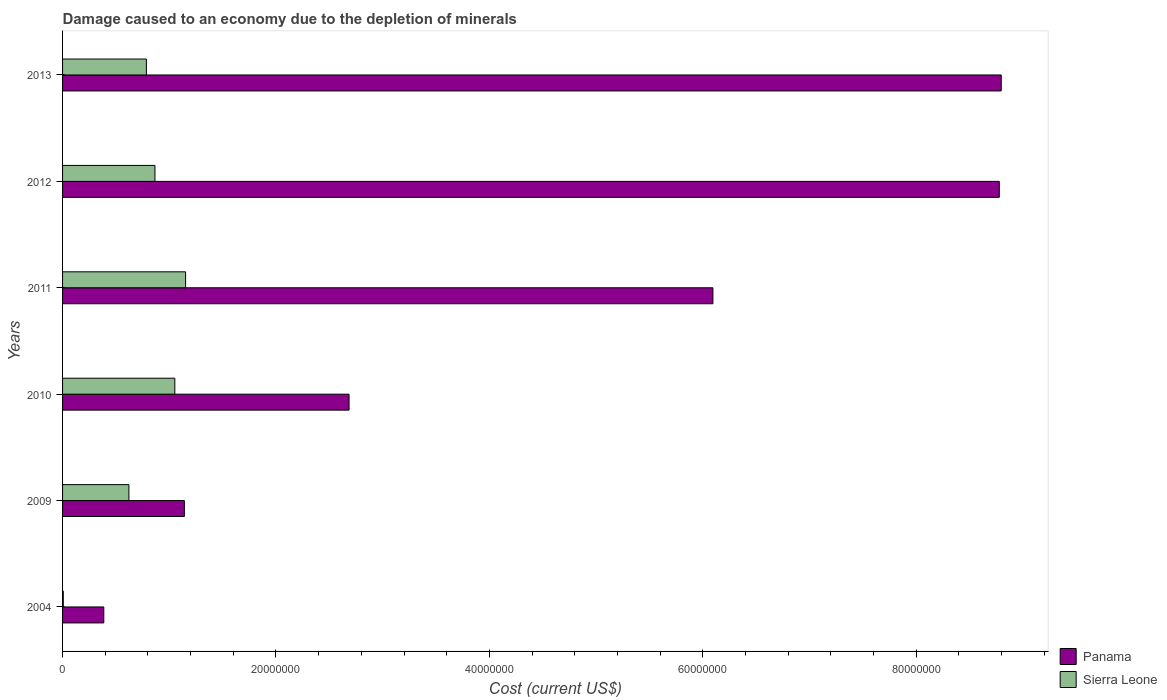Are the number of bars per tick equal to the number of legend labels?
Give a very brief answer. Yes. How many bars are there on the 3rd tick from the top?
Offer a very short reply. 2. What is the label of the 2nd group of bars from the top?
Offer a terse response. 2012. What is the cost of damage caused due to the depletion of minerals in Sierra Leone in 2012?
Provide a succinct answer. 8.66e+06. Across all years, what is the maximum cost of damage caused due to the depletion of minerals in Sierra Leone?
Give a very brief answer. 1.15e+07. Across all years, what is the minimum cost of damage caused due to the depletion of minerals in Panama?
Make the answer very short. 3.86e+06. In which year was the cost of damage caused due to the depletion of minerals in Panama maximum?
Keep it short and to the point. 2013. What is the total cost of damage caused due to the depletion of minerals in Panama in the graph?
Your answer should be compact. 2.79e+08. What is the difference between the cost of damage caused due to the depletion of minerals in Panama in 2010 and that in 2012?
Your answer should be compact. -6.09e+07. What is the difference between the cost of damage caused due to the depletion of minerals in Sierra Leone in 2010 and the cost of damage caused due to the depletion of minerals in Panama in 2012?
Offer a terse response. -7.73e+07. What is the average cost of damage caused due to the depletion of minerals in Sierra Leone per year?
Make the answer very short. 7.48e+06. In the year 2009, what is the difference between the cost of damage caused due to the depletion of minerals in Panama and cost of damage caused due to the depletion of minerals in Sierra Leone?
Keep it short and to the point. 5.20e+06. What is the ratio of the cost of damage caused due to the depletion of minerals in Panama in 2011 to that in 2013?
Offer a very short reply. 0.69. Is the difference between the cost of damage caused due to the depletion of minerals in Panama in 2004 and 2009 greater than the difference between the cost of damage caused due to the depletion of minerals in Sierra Leone in 2004 and 2009?
Your response must be concise. No. What is the difference between the highest and the second highest cost of damage caused due to the depletion of minerals in Panama?
Provide a short and direct response. 1.81e+05. What is the difference between the highest and the lowest cost of damage caused due to the depletion of minerals in Sierra Leone?
Your answer should be compact. 1.15e+07. In how many years, is the cost of damage caused due to the depletion of minerals in Sierra Leone greater than the average cost of damage caused due to the depletion of minerals in Sierra Leone taken over all years?
Your response must be concise. 4. Is the sum of the cost of damage caused due to the depletion of minerals in Panama in 2004 and 2013 greater than the maximum cost of damage caused due to the depletion of minerals in Sierra Leone across all years?
Offer a very short reply. Yes. What does the 1st bar from the top in 2004 represents?
Your response must be concise. Sierra Leone. What does the 2nd bar from the bottom in 2012 represents?
Your response must be concise. Sierra Leone. How many years are there in the graph?
Offer a very short reply. 6. What is the difference between two consecutive major ticks on the X-axis?
Offer a terse response. 2.00e+07. Are the values on the major ticks of X-axis written in scientific E-notation?
Your response must be concise. No. How are the legend labels stacked?
Your response must be concise. Vertical. What is the title of the graph?
Give a very brief answer. Damage caused to an economy due to the depletion of minerals. What is the label or title of the X-axis?
Offer a very short reply. Cost (current US$). What is the label or title of the Y-axis?
Keep it short and to the point. Years. What is the Cost (current US$) in Panama in 2004?
Your answer should be very brief. 3.86e+06. What is the Cost (current US$) of Sierra Leone in 2004?
Keep it short and to the point. 6.80e+04. What is the Cost (current US$) in Panama in 2009?
Offer a very short reply. 1.14e+07. What is the Cost (current US$) in Sierra Leone in 2009?
Offer a very short reply. 6.22e+06. What is the Cost (current US$) in Panama in 2010?
Ensure brevity in your answer.  2.69e+07. What is the Cost (current US$) in Sierra Leone in 2010?
Keep it short and to the point. 1.05e+07. What is the Cost (current US$) of Panama in 2011?
Your answer should be compact. 6.10e+07. What is the Cost (current US$) in Sierra Leone in 2011?
Provide a short and direct response. 1.15e+07. What is the Cost (current US$) in Panama in 2012?
Make the answer very short. 8.78e+07. What is the Cost (current US$) of Sierra Leone in 2012?
Your response must be concise. 8.66e+06. What is the Cost (current US$) in Panama in 2013?
Provide a succinct answer. 8.80e+07. What is the Cost (current US$) of Sierra Leone in 2013?
Give a very brief answer. 7.86e+06. Across all years, what is the maximum Cost (current US$) in Panama?
Your answer should be compact. 8.80e+07. Across all years, what is the maximum Cost (current US$) in Sierra Leone?
Keep it short and to the point. 1.15e+07. Across all years, what is the minimum Cost (current US$) of Panama?
Offer a terse response. 3.86e+06. Across all years, what is the minimum Cost (current US$) of Sierra Leone?
Offer a terse response. 6.80e+04. What is the total Cost (current US$) in Panama in the graph?
Your answer should be compact. 2.79e+08. What is the total Cost (current US$) of Sierra Leone in the graph?
Your answer should be very brief. 4.49e+07. What is the difference between the Cost (current US$) in Panama in 2004 and that in 2009?
Provide a short and direct response. -7.55e+06. What is the difference between the Cost (current US$) in Sierra Leone in 2004 and that in 2009?
Keep it short and to the point. -6.15e+06. What is the difference between the Cost (current US$) in Panama in 2004 and that in 2010?
Make the answer very short. -2.30e+07. What is the difference between the Cost (current US$) of Sierra Leone in 2004 and that in 2010?
Keep it short and to the point. -1.05e+07. What is the difference between the Cost (current US$) of Panama in 2004 and that in 2011?
Keep it short and to the point. -5.71e+07. What is the difference between the Cost (current US$) of Sierra Leone in 2004 and that in 2011?
Your response must be concise. -1.15e+07. What is the difference between the Cost (current US$) in Panama in 2004 and that in 2012?
Offer a terse response. -8.39e+07. What is the difference between the Cost (current US$) in Sierra Leone in 2004 and that in 2012?
Your answer should be compact. -8.59e+06. What is the difference between the Cost (current US$) of Panama in 2004 and that in 2013?
Offer a terse response. -8.41e+07. What is the difference between the Cost (current US$) in Sierra Leone in 2004 and that in 2013?
Ensure brevity in your answer.  -7.79e+06. What is the difference between the Cost (current US$) in Panama in 2009 and that in 2010?
Your answer should be compact. -1.54e+07. What is the difference between the Cost (current US$) in Sierra Leone in 2009 and that in 2010?
Provide a succinct answer. -4.30e+06. What is the difference between the Cost (current US$) of Panama in 2009 and that in 2011?
Give a very brief answer. -4.95e+07. What is the difference between the Cost (current US$) of Sierra Leone in 2009 and that in 2011?
Your answer should be very brief. -5.31e+06. What is the difference between the Cost (current US$) in Panama in 2009 and that in 2012?
Keep it short and to the point. -7.64e+07. What is the difference between the Cost (current US$) of Sierra Leone in 2009 and that in 2012?
Your answer should be compact. -2.44e+06. What is the difference between the Cost (current US$) of Panama in 2009 and that in 2013?
Your answer should be very brief. -7.66e+07. What is the difference between the Cost (current US$) in Sierra Leone in 2009 and that in 2013?
Offer a terse response. -1.64e+06. What is the difference between the Cost (current US$) of Panama in 2010 and that in 2011?
Your answer should be very brief. -3.41e+07. What is the difference between the Cost (current US$) in Sierra Leone in 2010 and that in 2011?
Keep it short and to the point. -1.01e+06. What is the difference between the Cost (current US$) in Panama in 2010 and that in 2012?
Your answer should be compact. -6.09e+07. What is the difference between the Cost (current US$) of Sierra Leone in 2010 and that in 2012?
Keep it short and to the point. 1.86e+06. What is the difference between the Cost (current US$) of Panama in 2010 and that in 2013?
Provide a short and direct response. -6.11e+07. What is the difference between the Cost (current US$) of Sierra Leone in 2010 and that in 2013?
Give a very brief answer. 2.66e+06. What is the difference between the Cost (current US$) of Panama in 2011 and that in 2012?
Ensure brevity in your answer.  -2.68e+07. What is the difference between the Cost (current US$) of Sierra Leone in 2011 and that in 2012?
Give a very brief answer. 2.87e+06. What is the difference between the Cost (current US$) in Panama in 2011 and that in 2013?
Offer a terse response. -2.70e+07. What is the difference between the Cost (current US$) of Sierra Leone in 2011 and that in 2013?
Offer a very short reply. 3.67e+06. What is the difference between the Cost (current US$) of Panama in 2012 and that in 2013?
Keep it short and to the point. -1.81e+05. What is the difference between the Cost (current US$) in Sierra Leone in 2012 and that in 2013?
Provide a succinct answer. 8.02e+05. What is the difference between the Cost (current US$) in Panama in 2004 and the Cost (current US$) in Sierra Leone in 2009?
Your answer should be very brief. -2.35e+06. What is the difference between the Cost (current US$) of Panama in 2004 and the Cost (current US$) of Sierra Leone in 2010?
Provide a succinct answer. -6.66e+06. What is the difference between the Cost (current US$) in Panama in 2004 and the Cost (current US$) in Sierra Leone in 2011?
Make the answer very short. -7.67e+06. What is the difference between the Cost (current US$) in Panama in 2004 and the Cost (current US$) in Sierra Leone in 2012?
Ensure brevity in your answer.  -4.80e+06. What is the difference between the Cost (current US$) of Panama in 2004 and the Cost (current US$) of Sierra Leone in 2013?
Give a very brief answer. -3.99e+06. What is the difference between the Cost (current US$) of Panama in 2009 and the Cost (current US$) of Sierra Leone in 2010?
Provide a short and direct response. 8.95e+05. What is the difference between the Cost (current US$) in Panama in 2009 and the Cost (current US$) in Sierra Leone in 2011?
Keep it short and to the point. -1.13e+05. What is the difference between the Cost (current US$) in Panama in 2009 and the Cost (current US$) in Sierra Leone in 2012?
Keep it short and to the point. 2.76e+06. What is the difference between the Cost (current US$) in Panama in 2009 and the Cost (current US$) in Sierra Leone in 2013?
Offer a very short reply. 3.56e+06. What is the difference between the Cost (current US$) in Panama in 2010 and the Cost (current US$) in Sierra Leone in 2011?
Make the answer very short. 1.53e+07. What is the difference between the Cost (current US$) of Panama in 2010 and the Cost (current US$) of Sierra Leone in 2012?
Give a very brief answer. 1.82e+07. What is the difference between the Cost (current US$) of Panama in 2010 and the Cost (current US$) of Sierra Leone in 2013?
Offer a terse response. 1.90e+07. What is the difference between the Cost (current US$) in Panama in 2011 and the Cost (current US$) in Sierra Leone in 2012?
Offer a very short reply. 5.23e+07. What is the difference between the Cost (current US$) of Panama in 2011 and the Cost (current US$) of Sierra Leone in 2013?
Give a very brief answer. 5.31e+07. What is the difference between the Cost (current US$) of Panama in 2012 and the Cost (current US$) of Sierra Leone in 2013?
Keep it short and to the point. 7.99e+07. What is the average Cost (current US$) of Panama per year?
Offer a very short reply. 4.65e+07. What is the average Cost (current US$) of Sierra Leone per year?
Give a very brief answer. 7.48e+06. In the year 2004, what is the difference between the Cost (current US$) of Panama and Cost (current US$) of Sierra Leone?
Your answer should be compact. 3.80e+06. In the year 2009, what is the difference between the Cost (current US$) in Panama and Cost (current US$) in Sierra Leone?
Your answer should be very brief. 5.20e+06. In the year 2010, what is the difference between the Cost (current US$) of Panama and Cost (current US$) of Sierra Leone?
Make the answer very short. 1.63e+07. In the year 2011, what is the difference between the Cost (current US$) in Panama and Cost (current US$) in Sierra Leone?
Your response must be concise. 4.94e+07. In the year 2012, what is the difference between the Cost (current US$) of Panama and Cost (current US$) of Sierra Leone?
Your answer should be very brief. 7.91e+07. In the year 2013, what is the difference between the Cost (current US$) of Panama and Cost (current US$) of Sierra Leone?
Provide a short and direct response. 8.01e+07. What is the ratio of the Cost (current US$) in Panama in 2004 to that in 2009?
Make the answer very short. 0.34. What is the ratio of the Cost (current US$) in Sierra Leone in 2004 to that in 2009?
Keep it short and to the point. 0.01. What is the ratio of the Cost (current US$) of Panama in 2004 to that in 2010?
Your answer should be very brief. 0.14. What is the ratio of the Cost (current US$) in Sierra Leone in 2004 to that in 2010?
Your response must be concise. 0.01. What is the ratio of the Cost (current US$) of Panama in 2004 to that in 2011?
Keep it short and to the point. 0.06. What is the ratio of the Cost (current US$) in Sierra Leone in 2004 to that in 2011?
Your answer should be compact. 0.01. What is the ratio of the Cost (current US$) in Panama in 2004 to that in 2012?
Provide a succinct answer. 0.04. What is the ratio of the Cost (current US$) of Sierra Leone in 2004 to that in 2012?
Provide a short and direct response. 0.01. What is the ratio of the Cost (current US$) of Panama in 2004 to that in 2013?
Give a very brief answer. 0.04. What is the ratio of the Cost (current US$) in Sierra Leone in 2004 to that in 2013?
Offer a very short reply. 0.01. What is the ratio of the Cost (current US$) of Panama in 2009 to that in 2010?
Make the answer very short. 0.43. What is the ratio of the Cost (current US$) in Sierra Leone in 2009 to that in 2010?
Offer a very short reply. 0.59. What is the ratio of the Cost (current US$) of Panama in 2009 to that in 2011?
Give a very brief answer. 0.19. What is the ratio of the Cost (current US$) of Sierra Leone in 2009 to that in 2011?
Provide a short and direct response. 0.54. What is the ratio of the Cost (current US$) of Panama in 2009 to that in 2012?
Provide a succinct answer. 0.13. What is the ratio of the Cost (current US$) in Sierra Leone in 2009 to that in 2012?
Your answer should be very brief. 0.72. What is the ratio of the Cost (current US$) of Panama in 2009 to that in 2013?
Ensure brevity in your answer.  0.13. What is the ratio of the Cost (current US$) in Sierra Leone in 2009 to that in 2013?
Give a very brief answer. 0.79. What is the ratio of the Cost (current US$) in Panama in 2010 to that in 2011?
Ensure brevity in your answer.  0.44. What is the ratio of the Cost (current US$) in Sierra Leone in 2010 to that in 2011?
Keep it short and to the point. 0.91. What is the ratio of the Cost (current US$) in Panama in 2010 to that in 2012?
Give a very brief answer. 0.31. What is the ratio of the Cost (current US$) of Sierra Leone in 2010 to that in 2012?
Your response must be concise. 1.22. What is the ratio of the Cost (current US$) of Panama in 2010 to that in 2013?
Ensure brevity in your answer.  0.31. What is the ratio of the Cost (current US$) in Sierra Leone in 2010 to that in 2013?
Your answer should be compact. 1.34. What is the ratio of the Cost (current US$) in Panama in 2011 to that in 2012?
Make the answer very short. 0.69. What is the ratio of the Cost (current US$) in Sierra Leone in 2011 to that in 2012?
Give a very brief answer. 1.33. What is the ratio of the Cost (current US$) of Panama in 2011 to that in 2013?
Ensure brevity in your answer.  0.69. What is the ratio of the Cost (current US$) of Sierra Leone in 2011 to that in 2013?
Your answer should be compact. 1.47. What is the ratio of the Cost (current US$) of Panama in 2012 to that in 2013?
Your answer should be compact. 1. What is the ratio of the Cost (current US$) of Sierra Leone in 2012 to that in 2013?
Your response must be concise. 1.1. What is the difference between the highest and the second highest Cost (current US$) of Panama?
Make the answer very short. 1.81e+05. What is the difference between the highest and the second highest Cost (current US$) in Sierra Leone?
Keep it short and to the point. 1.01e+06. What is the difference between the highest and the lowest Cost (current US$) in Panama?
Provide a short and direct response. 8.41e+07. What is the difference between the highest and the lowest Cost (current US$) in Sierra Leone?
Keep it short and to the point. 1.15e+07. 